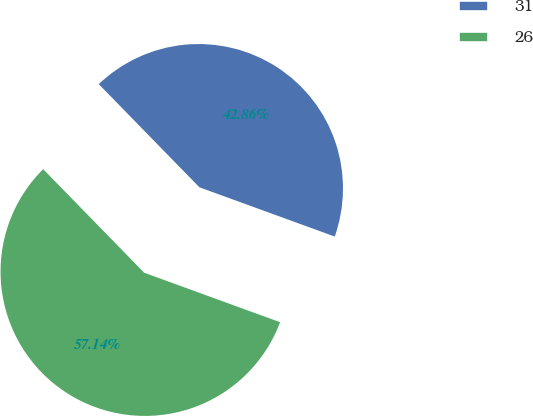<chart> <loc_0><loc_0><loc_500><loc_500><pie_chart><fcel>31<fcel>26<nl><fcel>42.86%<fcel>57.14%<nl></chart> 